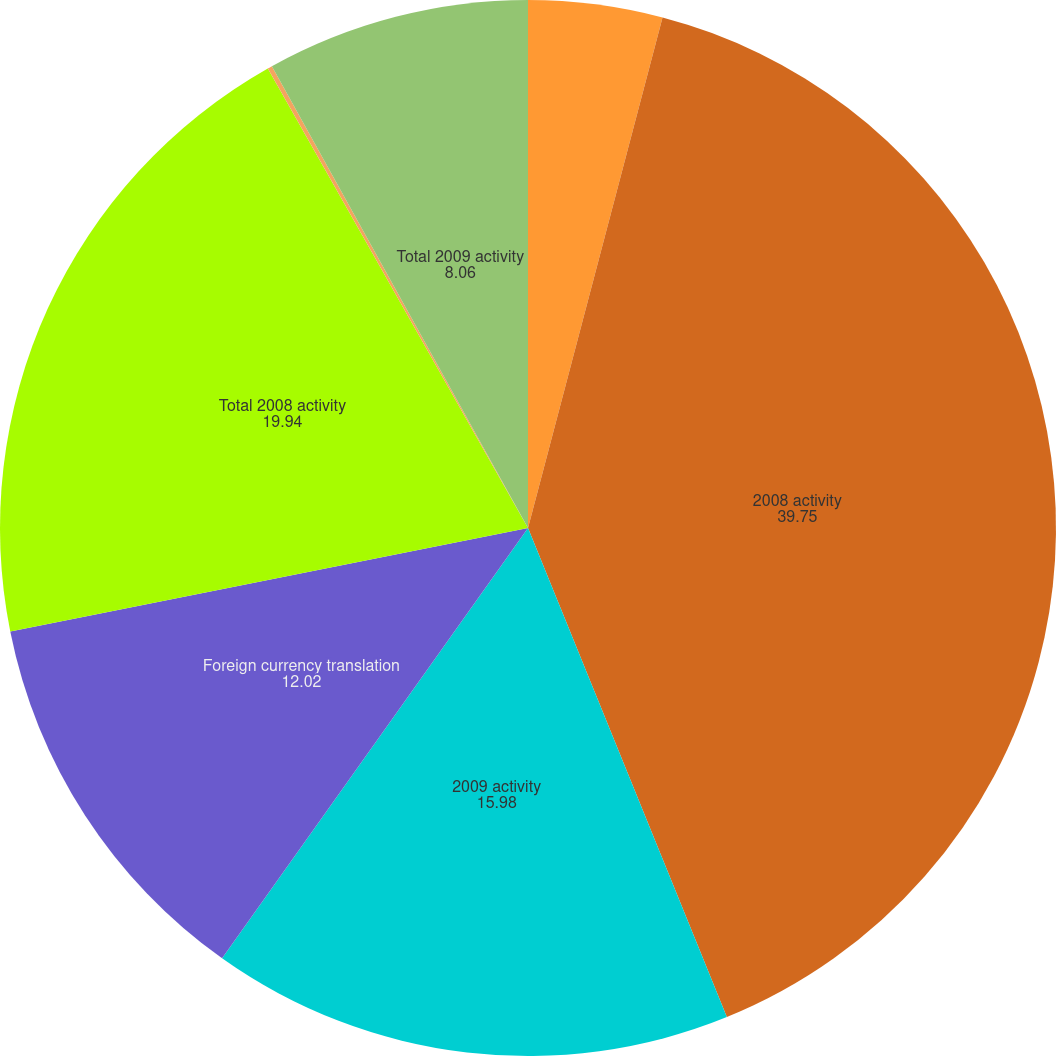Convert chart. <chart><loc_0><loc_0><loc_500><loc_500><pie_chart><fcel>2007 activity<fcel>2008 activity<fcel>2009 activity<fcel>Foreign currency translation<fcel>Total 2008 activity<fcel>SBA I/O strip valuation adj<fcel>Total 2009 activity<nl><fcel>4.1%<fcel>39.75%<fcel>15.98%<fcel>12.02%<fcel>19.94%<fcel>0.14%<fcel>8.06%<nl></chart> 